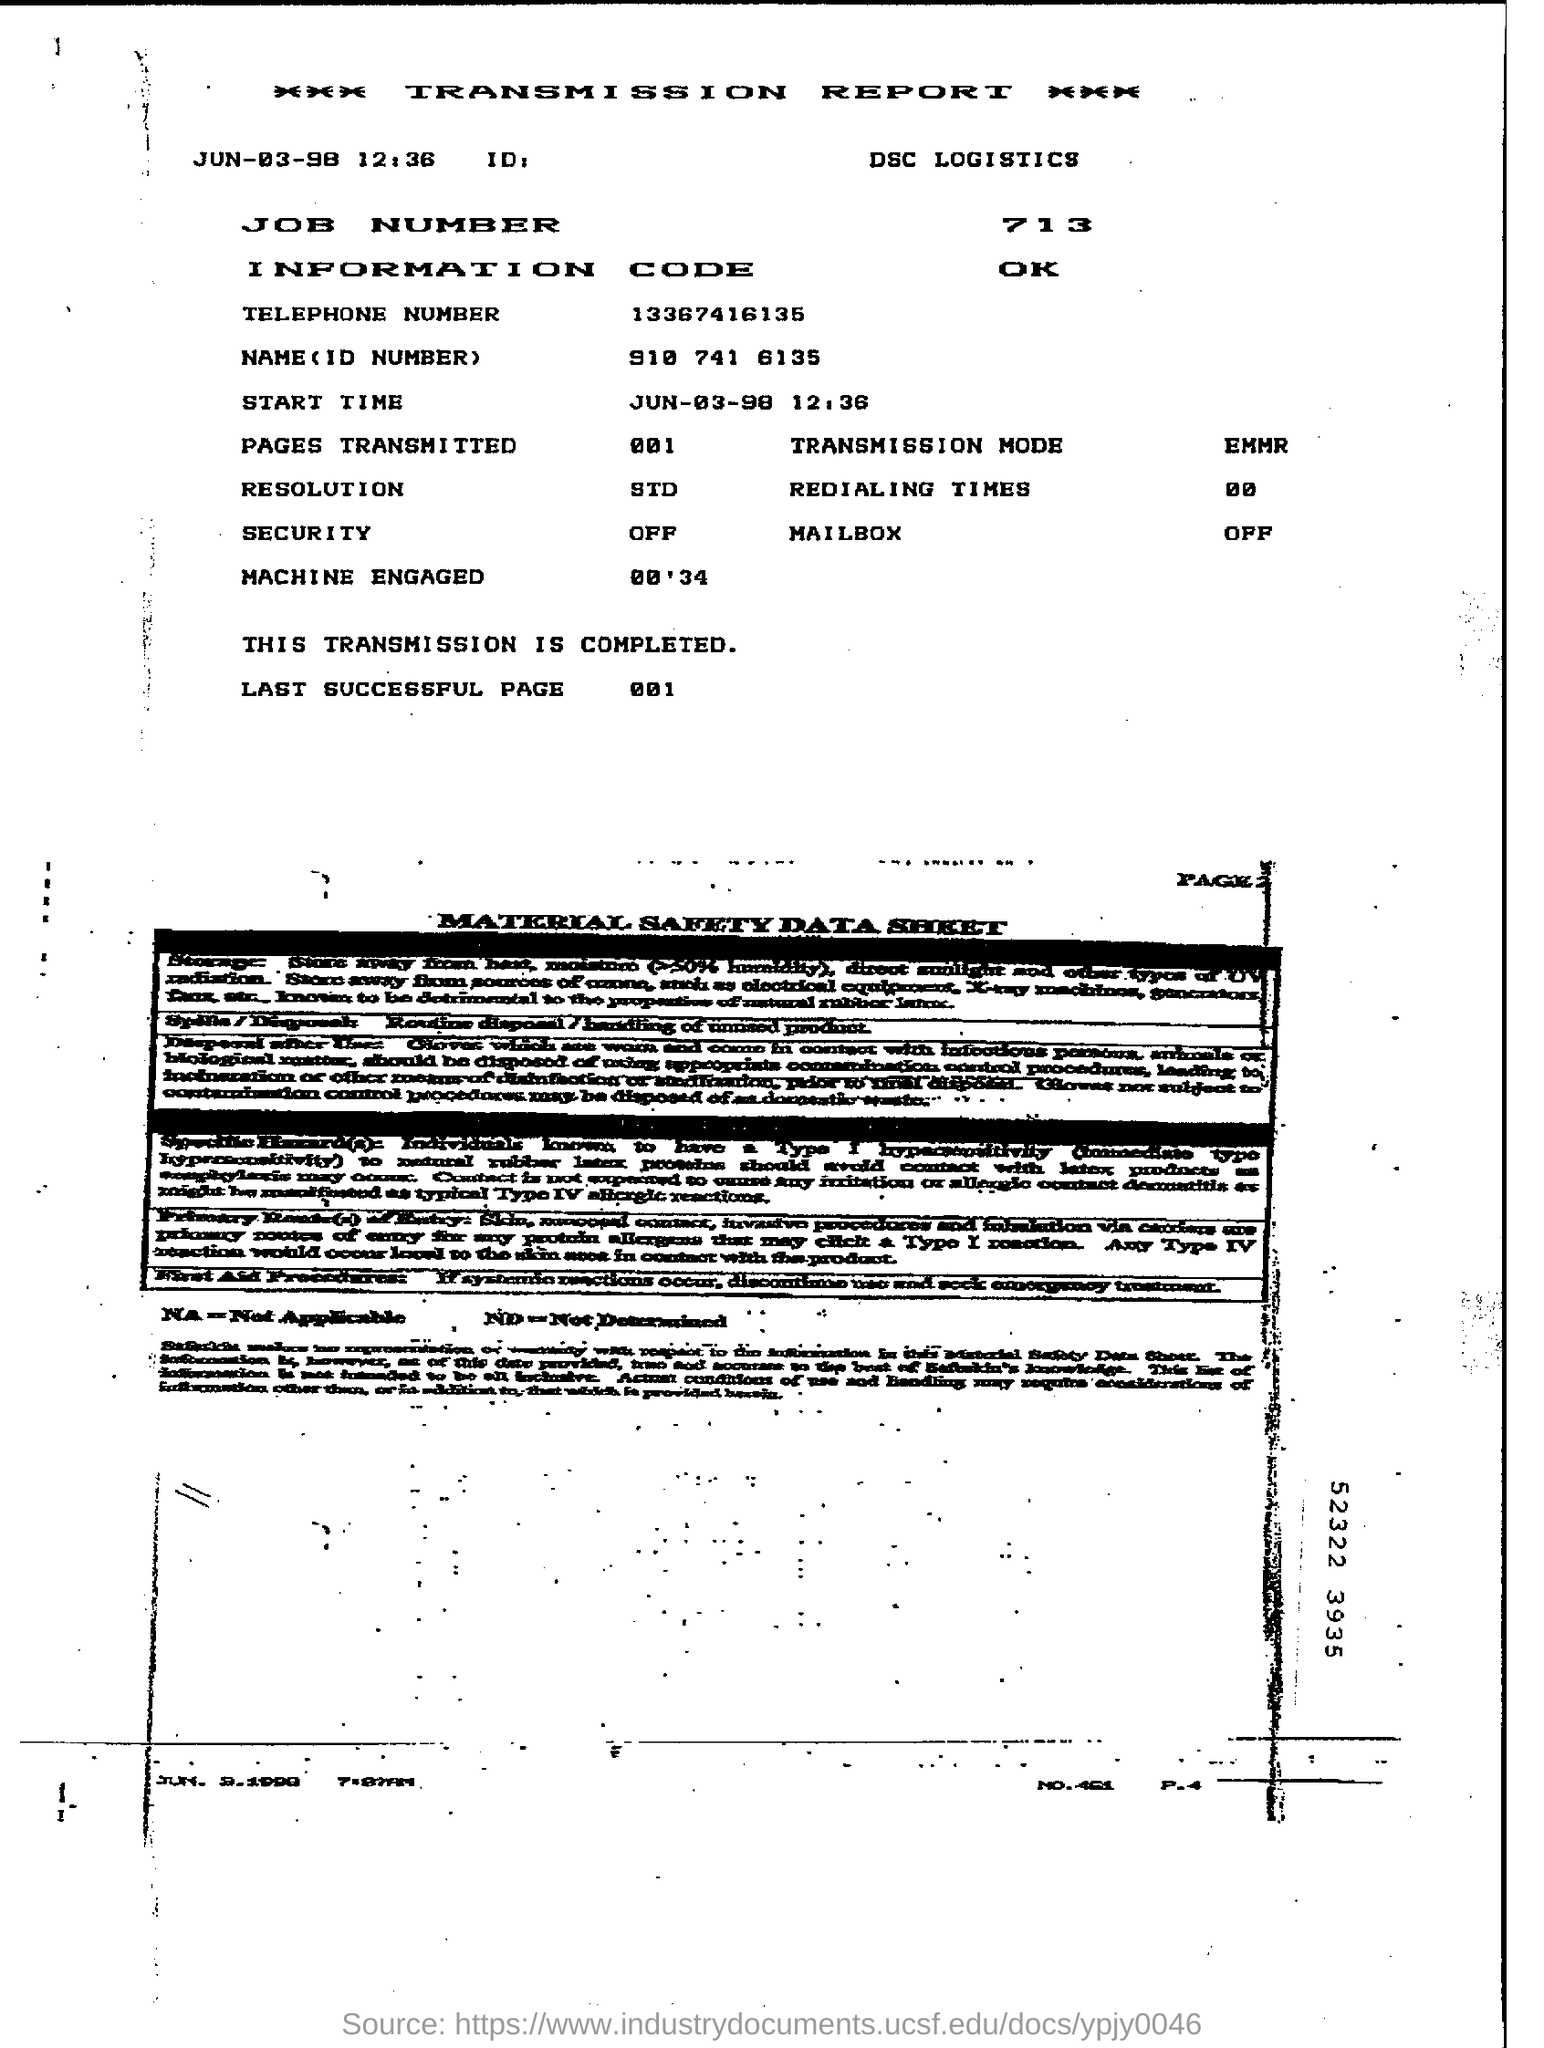Point out several critical features in this image. The job number mentioned in the report is 713... The security is currently turned off. The start time mentioned in the report is 12:36. The name and ID number given in the report are 910 741 6135. The transmission mode mentioned in the report is EMMR. 